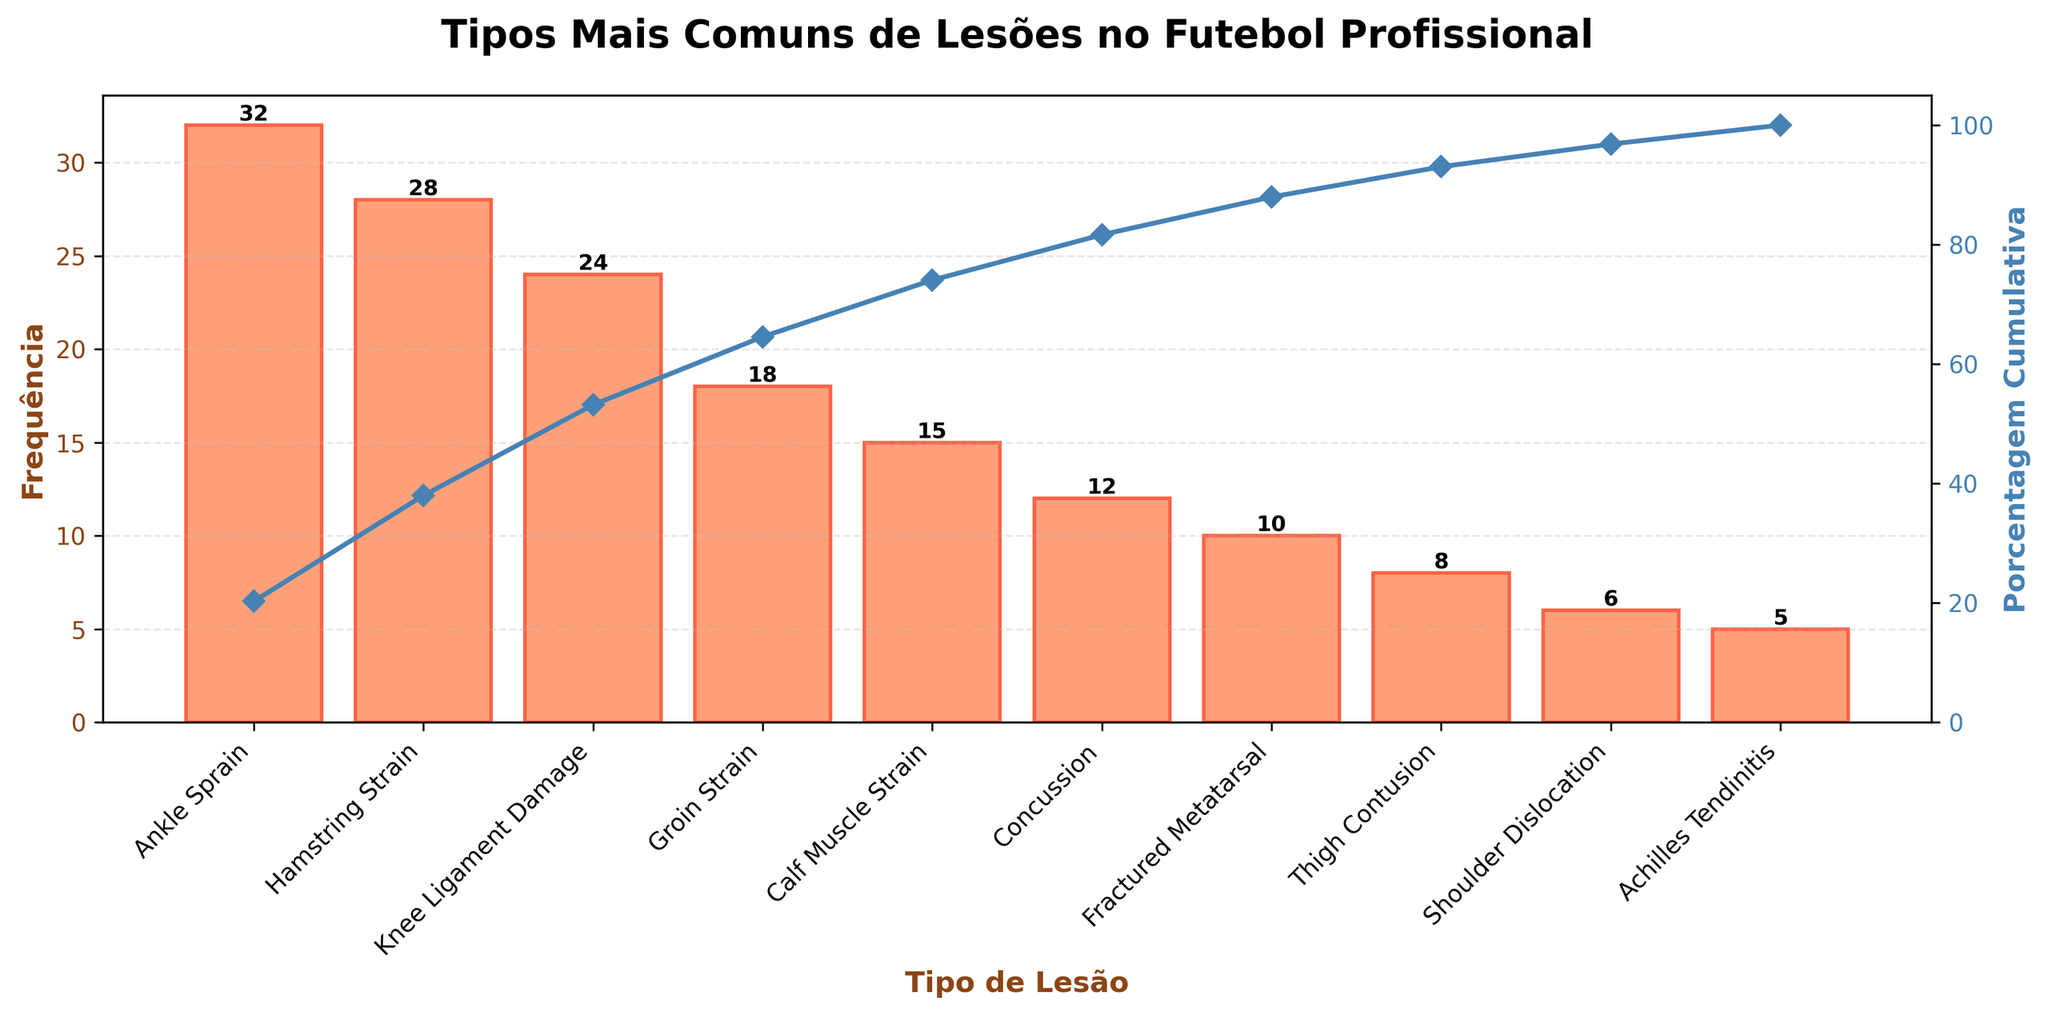What is the most common type of injury in professional football according to the chart? The most common type of injury can be identified as the one with the highest frequency bar. The tallest bar represents ‘Ankle Sprain’ with a frequency of 32.
Answer: Ankle Sprain What percentage of injuries are covered by ankle sprains, hamstring strains, and knee ligament damage combined? To get the combined percentage, first sum the frequencies: 32 (Ankle Sprain) + 28 (Hamstring Strain) + 24 (Knee Ligament Damage) = 84. Then, find the total frequency of all injuries which is 158. The combined percentage is (84 / 158) * 100 = 53.16%.
Answer: 53.16% Which injury type has the lowest frequency? The shortest bar in the graph represents the injury with the lowest frequency. The shortest bar is for ‘Achilles Tendinitis’ with a frequency of 5.
Answer: Achilles Tendinitis How many types of injuries are displayed in the chart? Count the number of distinct bars on the x-axis, each representing an injury type. There are 10 distinct injury types displayed in the chart.
Answer: 10 By what percentage does the cumulative percentage increase between groin strain and calf muscle strain? The cumulative percentage after calf muscle strain is around 75%. After groin strain, it's around 60%. The increase in cumulative percentage is 75% - 60% = 15%.
Answer: 15% Compare the frequency of hamstring strains to calf muscle strains. How many more hamstring strains are there? The bar for hamstring strains shows a frequency of 28, and the bar for calf muscle strains shows a frequency of 15. Subtract the two: 28 - 15 = 13.
Answer: 13 What is the cumulative percentage after the first four injury types? The injury types are in the order Ankle Sprain (32), Hamstring Strain (28), Knee Ligament Damage (24), and Groin Strain (18). The cumulative frequency of the first four is 32 + 28 + 24 + 18 = 102. The cumulative percentage is (102 / 158) * 100 = 64.56%.
Answer: 64.56% Which injury type represents the midpoint (50%) in the cumulative percentage line? Observe the cumulative percentage line and find the point closest to 50%. It appears to cross the 50% mark after the ‘Knee Ligament Damage’.
Answer: Knee Ligament Damage 